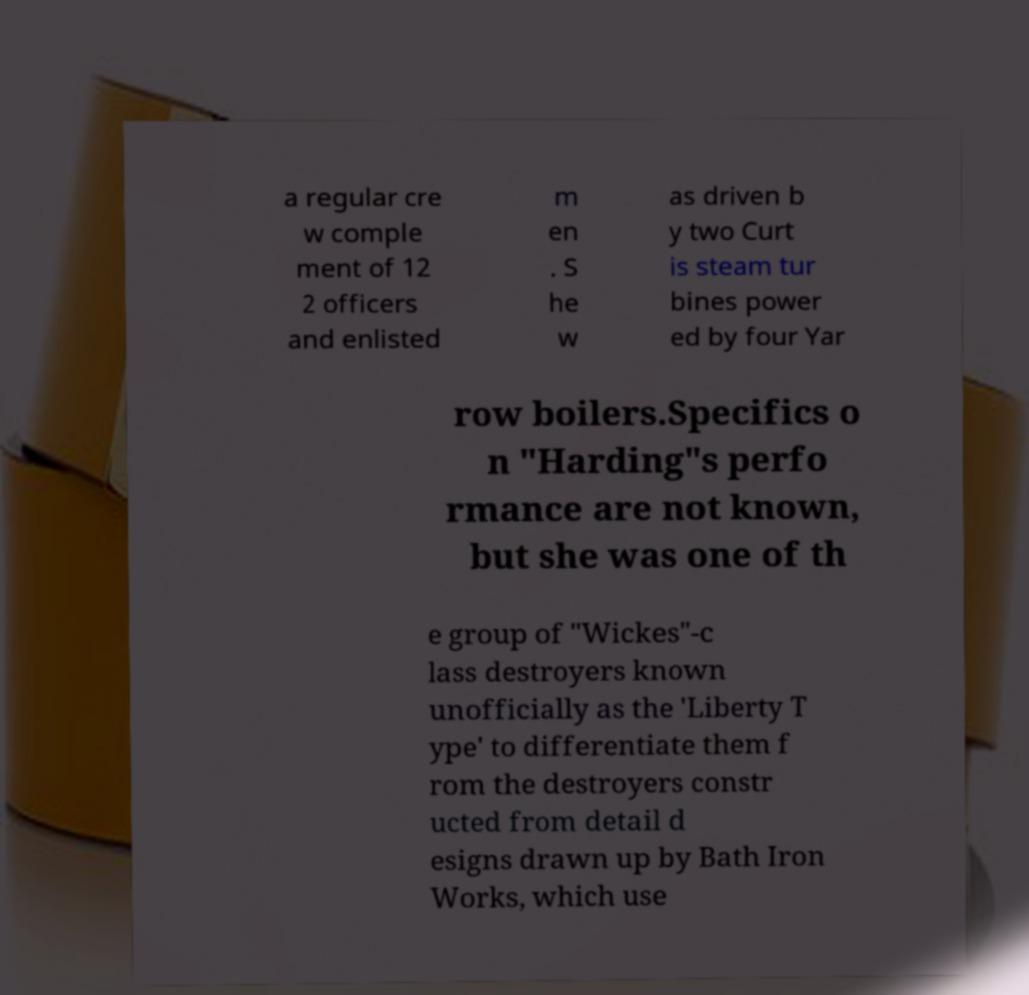Please identify and transcribe the text found in this image. a regular cre w comple ment of 12 2 officers and enlisted m en . S he w as driven b y two Curt is steam tur bines power ed by four Yar row boilers.Specifics o n "Harding"s perfo rmance are not known, but she was one of th e group of "Wickes"-c lass destroyers known unofficially as the 'Liberty T ype' to differentiate them f rom the destroyers constr ucted from detail d esigns drawn up by Bath Iron Works, which use 